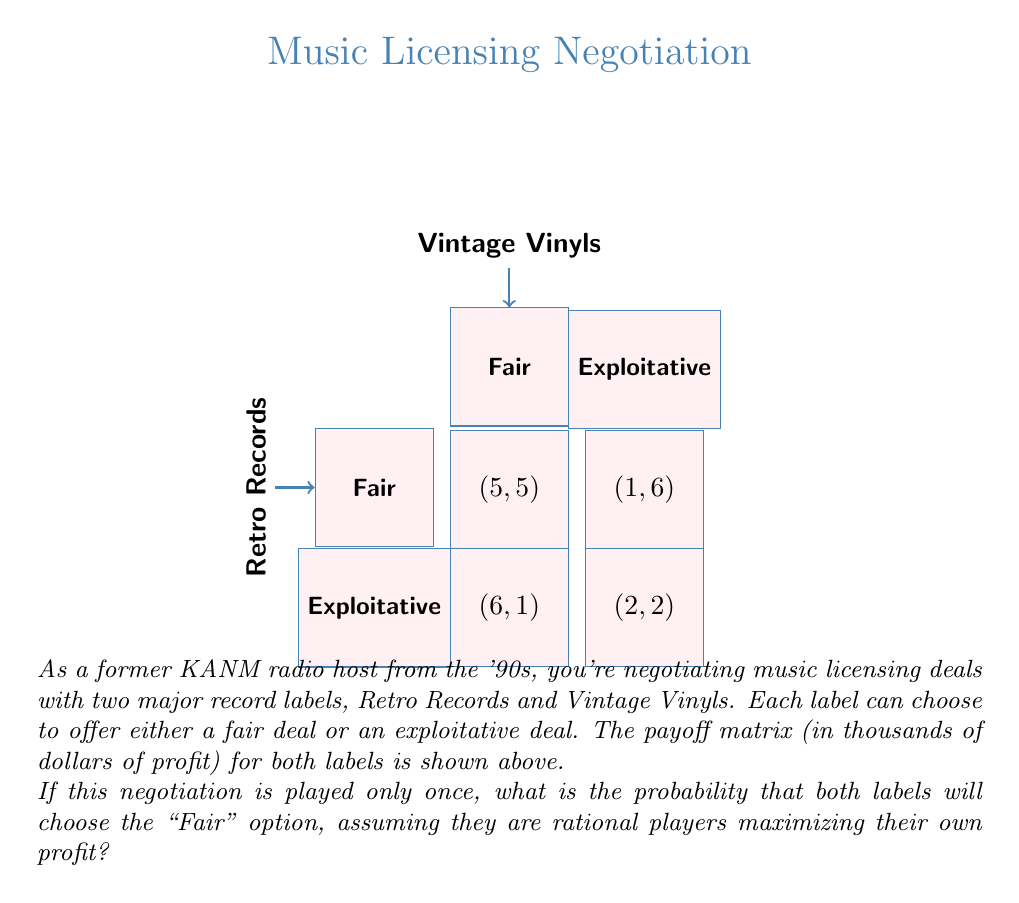Could you help me with this problem? To solve this problem, we need to analyze the prisoner's dilemma in the context of music licensing negotiations. Let's break it down step-by-step:

1) First, we need to identify the dominant strategy for each player. A dominant strategy is one that yields the highest payoff regardless of what the other player does.

2) For Retro Records:
   - If Vintage Vinyls chooses Fair: $6 > 5$, so Exploitative is better
   - If Vintage Vinyls chooses Exploitative: $2 > 1$, so Exploitative is better

3) For Vintage Vinyls:
   - If Retro Records chooses Fair: $6 > 5$, so Exploitative is better
   - If Retro Records chooses Exploitative: $2 > 1$, so Exploitative is better

4) We can see that for both labels, the dominant strategy is to choose Exploitative, regardless of what the other label does.

5) In game theory, when both players have a dominant strategy, the outcome where both players play their dominant strategy is called the Nash equilibrium.

6) The Nash equilibrium in this case is (Exploitative, Exploitative), resulting in a payoff of (2, 2).

7) Given that both players are rational and seeking to maximize their own profit, they will always choose their dominant strategy.

8) Therefore, the probability of both labels choosing the "Fair" option is 0.

9) We can express this probability mathematically as:

   $$P(\text{Both Fair}) = 0$$

This outcome demonstrates the classic prisoner's dilemma, where individual rational decisions lead to a suboptimal outcome for both parties. If they could cooperate and both choose "Fair", they would each get a better payoff of 5 instead of 2.
Answer: 0 